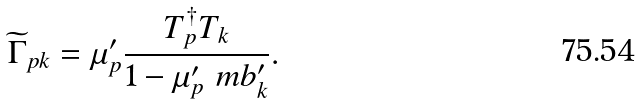<formula> <loc_0><loc_0><loc_500><loc_500>\widetilde { \Gamma } _ { p k } = \mu ^ { \prime } _ { p } \frac { T _ { p } ^ { \dag } T _ { k } } { 1 - \mu ^ { \prime } _ { p } \ m b ^ { \prime } _ { k } } .</formula> 